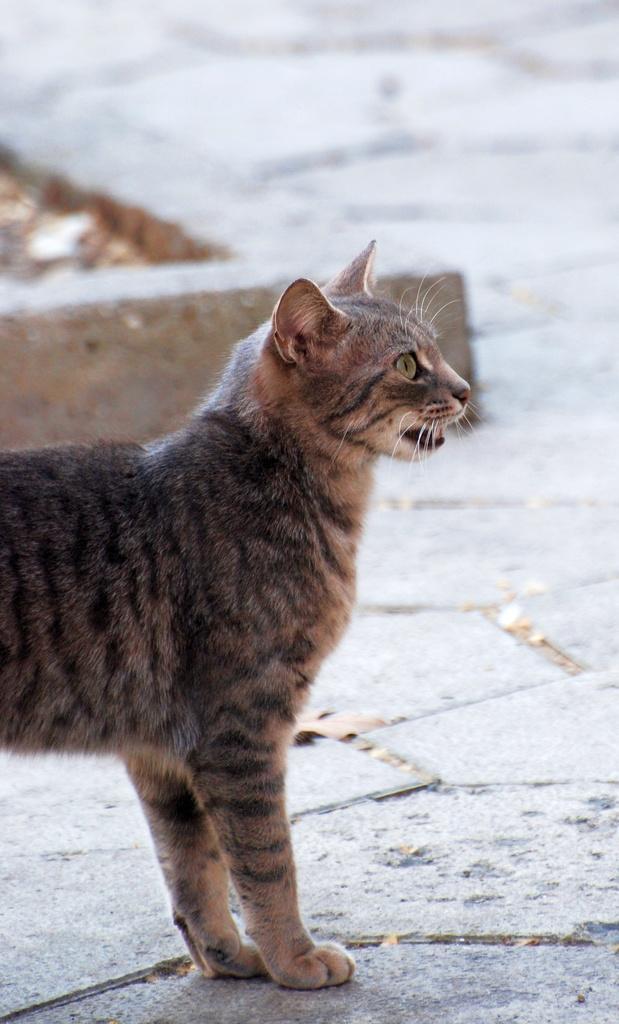How would you summarize this image in a sentence or two? This picture shows a cat. It is white black and grey in color. 